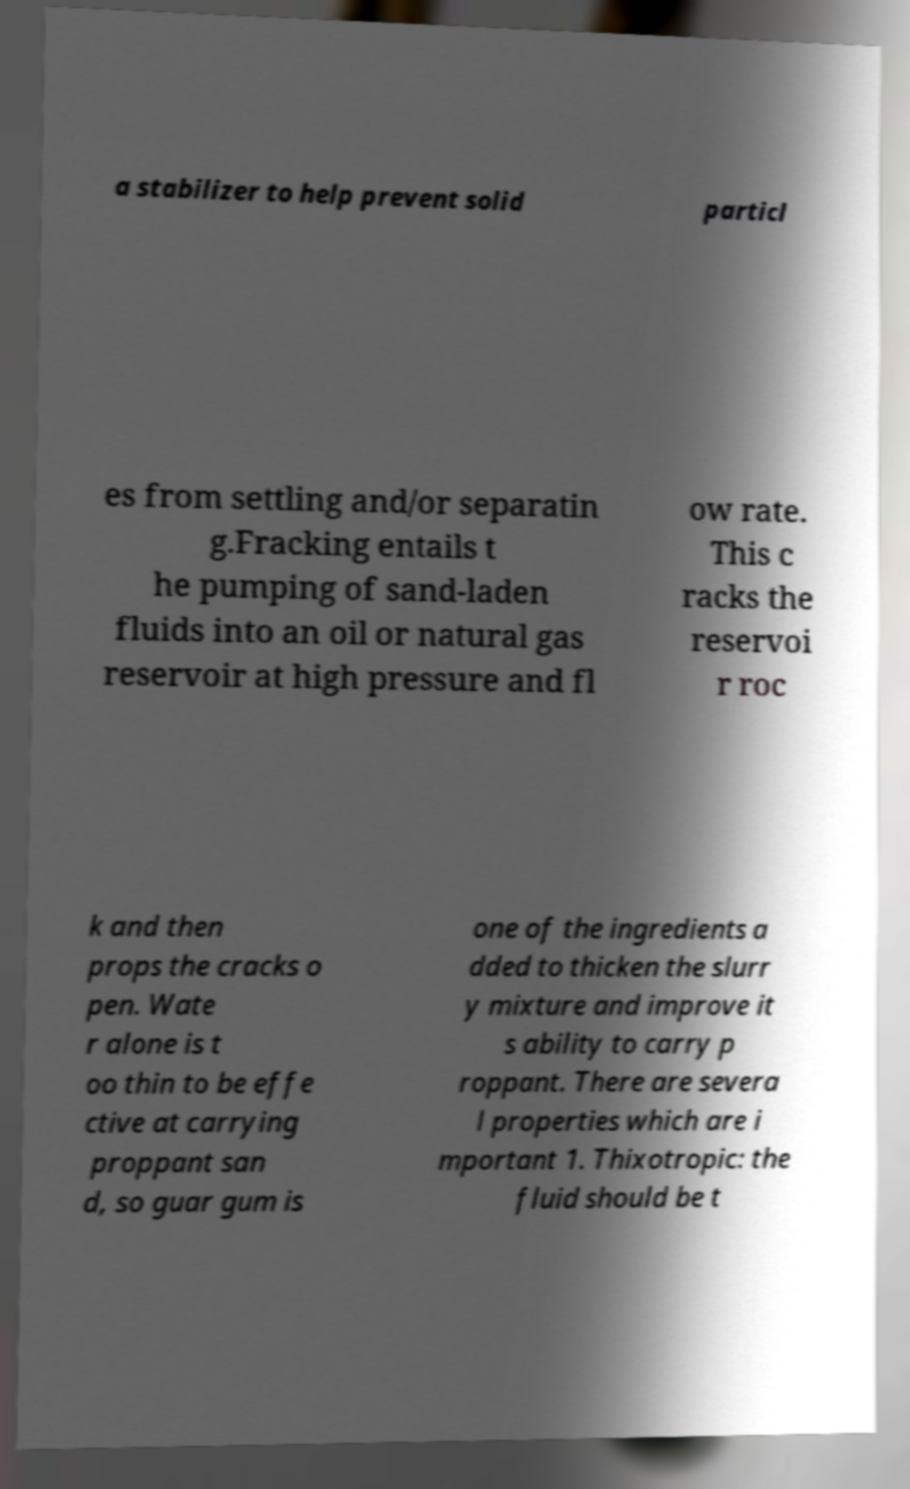Can you read and provide the text displayed in the image?This photo seems to have some interesting text. Can you extract and type it out for me? a stabilizer to help prevent solid particl es from settling and/or separatin g.Fracking entails t he pumping of sand-laden fluids into an oil or natural gas reservoir at high pressure and fl ow rate. This c racks the reservoi r roc k and then props the cracks o pen. Wate r alone is t oo thin to be effe ctive at carrying proppant san d, so guar gum is one of the ingredients a dded to thicken the slurr y mixture and improve it s ability to carry p roppant. There are severa l properties which are i mportant 1. Thixotropic: the fluid should be t 